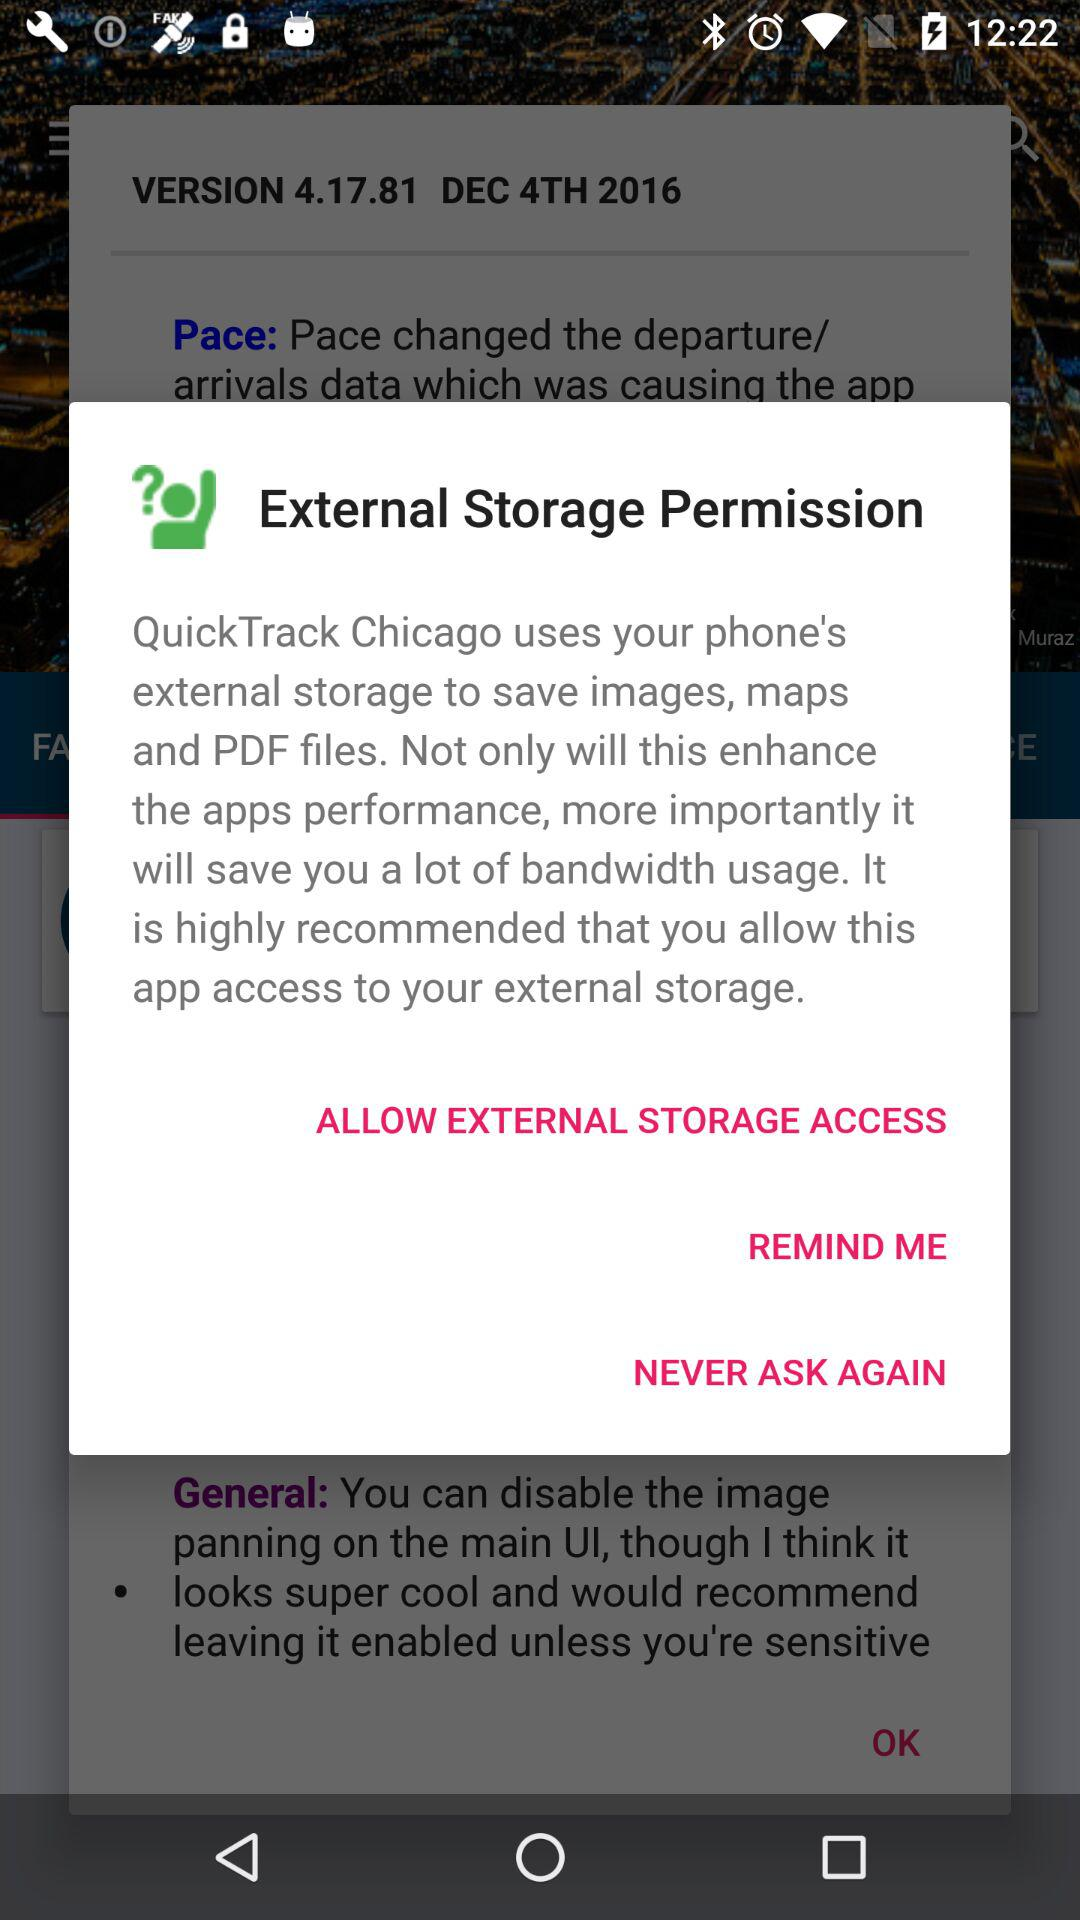What is the released version? The released version is 4.17.81. 